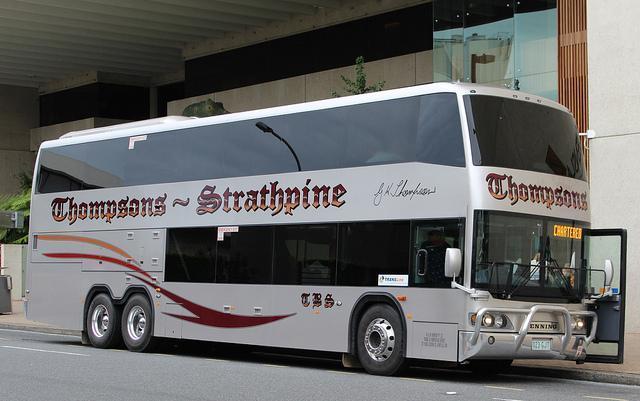How many levels does the bus have?
Give a very brief answer. 2. How many rolls of toilet paper are on top of the toilet?
Give a very brief answer. 0. 